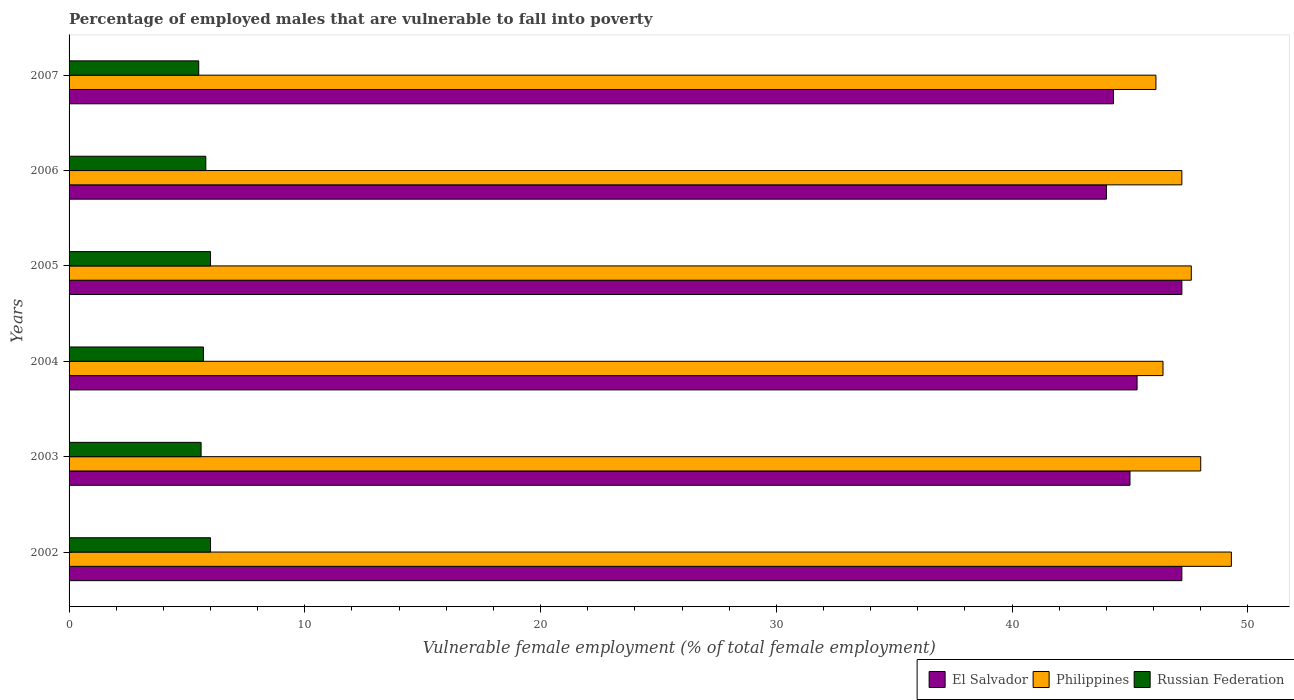How many groups of bars are there?
Give a very brief answer. 6. Are the number of bars on each tick of the Y-axis equal?
Make the answer very short. Yes. How many bars are there on the 4th tick from the top?
Your response must be concise. 3. What is the percentage of employed males who are vulnerable to fall into poverty in Philippines in 2002?
Give a very brief answer. 49.3. Across all years, what is the maximum percentage of employed males who are vulnerable to fall into poverty in El Salvador?
Provide a succinct answer. 47.2. Across all years, what is the minimum percentage of employed males who are vulnerable to fall into poverty in Philippines?
Give a very brief answer. 46.1. In which year was the percentage of employed males who are vulnerable to fall into poverty in El Salvador minimum?
Offer a very short reply. 2006. What is the total percentage of employed males who are vulnerable to fall into poverty in El Salvador in the graph?
Provide a succinct answer. 273. What is the difference between the percentage of employed males who are vulnerable to fall into poverty in Philippines in 2004 and that in 2006?
Give a very brief answer. -0.8. What is the average percentage of employed males who are vulnerable to fall into poverty in El Salvador per year?
Your answer should be very brief. 45.5. In the year 2007, what is the difference between the percentage of employed males who are vulnerable to fall into poverty in El Salvador and percentage of employed males who are vulnerable to fall into poverty in Russian Federation?
Offer a terse response. 38.8. What is the ratio of the percentage of employed males who are vulnerable to fall into poverty in Russian Federation in 2002 to that in 2006?
Your answer should be very brief. 1.03. What is the difference between the highest and the second highest percentage of employed males who are vulnerable to fall into poverty in Russian Federation?
Offer a terse response. 0. What is the difference between the highest and the lowest percentage of employed males who are vulnerable to fall into poverty in El Salvador?
Provide a short and direct response. 3.2. What does the 3rd bar from the top in 2003 represents?
Give a very brief answer. El Salvador. What does the 1st bar from the bottom in 2004 represents?
Provide a succinct answer. El Salvador. Is it the case that in every year, the sum of the percentage of employed males who are vulnerable to fall into poverty in Philippines and percentage of employed males who are vulnerable to fall into poverty in Russian Federation is greater than the percentage of employed males who are vulnerable to fall into poverty in El Salvador?
Offer a very short reply. Yes. How many bars are there?
Give a very brief answer. 18. Are all the bars in the graph horizontal?
Offer a very short reply. Yes. What is the difference between two consecutive major ticks on the X-axis?
Your response must be concise. 10. Are the values on the major ticks of X-axis written in scientific E-notation?
Ensure brevity in your answer.  No. Does the graph contain grids?
Your response must be concise. No. How are the legend labels stacked?
Your response must be concise. Horizontal. What is the title of the graph?
Offer a terse response. Percentage of employed males that are vulnerable to fall into poverty. Does "Albania" appear as one of the legend labels in the graph?
Give a very brief answer. No. What is the label or title of the X-axis?
Ensure brevity in your answer.  Vulnerable female employment (% of total female employment). What is the label or title of the Y-axis?
Provide a short and direct response. Years. What is the Vulnerable female employment (% of total female employment) of El Salvador in 2002?
Your response must be concise. 47.2. What is the Vulnerable female employment (% of total female employment) in Philippines in 2002?
Your response must be concise. 49.3. What is the Vulnerable female employment (% of total female employment) in Philippines in 2003?
Your answer should be compact. 48. What is the Vulnerable female employment (% of total female employment) in Russian Federation in 2003?
Ensure brevity in your answer.  5.6. What is the Vulnerable female employment (% of total female employment) of El Salvador in 2004?
Your answer should be very brief. 45.3. What is the Vulnerable female employment (% of total female employment) of Philippines in 2004?
Your response must be concise. 46.4. What is the Vulnerable female employment (% of total female employment) in Russian Federation in 2004?
Your answer should be very brief. 5.7. What is the Vulnerable female employment (% of total female employment) of El Salvador in 2005?
Give a very brief answer. 47.2. What is the Vulnerable female employment (% of total female employment) of Philippines in 2005?
Provide a succinct answer. 47.6. What is the Vulnerable female employment (% of total female employment) of Russian Federation in 2005?
Your answer should be very brief. 6. What is the Vulnerable female employment (% of total female employment) in Philippines in 2006?
Provide a short and direct response. 47.2. What is the Vulnerable female employment (% of total female employment) of Russian Federation in 2006?
Keep it short and to the point. 5.8. What is the Vulnerable female employment (% of total female employment) of El Salvador in 2007?
Your answer should be compact. 44.3. What is the Vulnerable female employment (% of total female employment) of Philippines in 2007?
Provide a short and direct response. 46.1. What is the Vulnerable female employment (% of total female employment) of Russian Federation in 2007?
Your answer should be very brief. 5.5. Across all years, what is the maximum Vulnerable female employment (% of total female employment) in El Salvador?
Make the answer very short. 47.2. Across all years, what is the maximum Vulnerable female employment (% of total female employment) of Philippines?
Offer a terse response. 49.3. Across all years, what is the minimum Vulnerable female employment (% of total female employment) in El Salvador?
Keep it short and to the point. 44. Across all years, what is the minimum Vulnerable female employment (% of total female employment) in Philippines?
Ensure brevity in your answer.  46.1. What is the total Vulnerable female employment (% of total female employment) of El Salvador in the graph?
Ensure brevity in your answer.  273. What is the total Vulnerable female employment (% of total female employment) of Philippines in the graph?
Offer a terse response. 284.6. What is the total Vulnerable female employment (% of total female employment) of Russian Federation in the graph?
Make the answer very short. 34.6. What is the difference between the Vulnerable female employment (% of total female employment) in El Salvador in 2002 and that in 2003?
Your answer should be compact. 2.2. What is the difference between the Vulnerable female employment (% of total female employment) in Philippines in 2002 and that in 2003?
Your answer should be compact. 1.3. What is the difference between the Vulnerable female employment (% of total female employment) of Russian Federation in 2002 and that in 2003?
Give a very brief answer. 0.4. What is the difference between the Vulnerable female employment (% of total female employment) in Philippines in 2002 and that in 2005?
Your response must be concise. 1.7. What is the difference between the Vulnerable female employment (% of total female employment) in Russian Federation in 2002 and that in 2005?
Provide a short and direct response. 0. What is the difference between the Vulnerable female employment (% of total female employment) of Philippines in 2002 and that in 2006?
Your answer should be very brief. 2.1. What is the difference between the Vulnerable female employment (% of total female employment) in Russian Federation in 2002 and that in 2006?
Offer a very short reply. 0.2. What is the difference between the Vulnerable female employment (% of total female employment) of Philippines in 2002 and that in 2007?
Offer a terse response. 3.2. What is the difference between the Vulnerable female employment (% of total female employment) of Russian Federation in 2002 and that in 2007?
Your answer should be very brief. 0.5. What is the difference between the Vulnerable female employment (% of total female employment) of Philippines in 2003 and that in 2004?
Provide a succinct answer. 1.6. What is the difference between the Vulnerable female employment (% of total female employment) in Russian Federation in 2003 and that in 2004?
Provide a short and direct response. -0.1. What is the difference between the Vulnerable female employment (% of total female employment) in El Salvador in 2003 and that in 2005?
Provide a short and direct response. -2.2. What is the difference between the Vulnerable female employment (% of total female employment) in Philippines in 2003 and that in 2005?
Ensure brevity in your answer.  0.4. What is the difference between the Vulnerable female employment (% of total female employment) in Russian Federation in 2003 and that in 2005?
Make the answer very short. -0.4. What is the difference between the Vulnerable female employment (% of total female employment) of El Salvador in 2003 and that in 2006?
Provide a short and direct response. 1. What is the difference between the Vulnerable female employment (% of total female employment) in Russian Federation in 2003 and that in 2006?
Give a very brief answer. -0.2. What is the difference between the Vulnerable female employment (% of total female employment) in Russian Federation in 2003 and that in 2007?
Offer a terse response. 0.1. What is the difference between the Vulnerable female employment (% of total female employment) of El Salvador in 2004 and that in 2005?
Provide a succinct answer. -1.9. What is the difference between the Vulnerable female employment (% of total female employment) in Philippines in 2004 and that in 2005?
Your answer should be compact. -1.2. What is the difference between the Vulnerable female employment (% of total female employment) in El Salvador in 2004 and that in 2006?
Your answer should be compact. 1.3. What is the difference between the Vulnerable female employment (% of total female employment) in Philippines in 2004 and that in 2006?
Give a very brief answer. -0.8. What is the difference between the Vulnerable female employment (% of total female employment) in Russian Federation in 2004 and that in 2006?
Ensure brevity in your answer.  -0.1. What is the difference between the Vulnerable female employment (% of total female employment) of El Salvador in 2004 and that in 2007?
Provide a succinct answer. 1. What is the difference between the Vulnerable female employment (% of total female employment) of Philippines in 2004 and that in 2007?
Offer a terse response. 0.3. What is the difference between the Vulnerable female employment (% of total female employment) of Russian Federation in 2004 and that in 2007?
Your response must be concise. 0.2. What is the difference between the Vulnerable female employment (% of total female employment) in El Salvador in 2005 and that in 2006?
Offer a very short reply. 3.2. What is the difference between the Vulnerable female employment (% of total female employment) in Philippines in 2005 and that in 2006?
Offer a terse response. 0.4. What is the difference between the Vulnerable female employment (% of total female employment) in Russian Federation in 2005 and that in 2006?
Your response must be concise. 0.2. What is the difference between the Vulnerable female employment (% of total female employment) in El Salvador in 2005 and that in 2007?
Offer a very short reply. 2.9. What is the difference between the Vulnerable female employment (% of total female employment) in Philippines in 2005 and that in 2007?
Ensure brevity in your answer.  1.5. What is the difference between the Vulnerable female employment (% of total female employment) in Russian Federation in 2005 and that in 2007?
Your answer should be compact. 0.5. What is the difference between the Vulnerable female employment (% of total female employment) of Philippines in 2006 and that in 2007?
Your answer should be compact. 1.1. What is the difference between the Vulnerable female employment (% of total female employment) in Russian Federation in 2006 and that in 2007?
Offer a very short reply. 0.3. What is the difference between the Vulnerable female employment (% of total female employment) in El Salvador in 2002 and the Vulnerable female employment (% of total female employment) in Russian Federation in 2003?
Provide a succinct answer. 41.6. What is the difference between the Vulnerable female employment (% of total female employment) of Philippines in 2002 and the Vulnerable female employment (% of total female employment) of Russian Federation in 2003?
Keep it short and to the point. 43.7. What is the difference between the Vulnerable female employment (% of total female employment) in El Salvador in 2002 and the Vulnerable female employment (% of total female employment) in Russian Federation in 2004?
Provide a succinct answer. 41.5. What is the difference between the Vulnerable female employment (% of total female employment) in Philippines in 2002 and the Vulnerable female employment (% of total female employment) in Russian Federation in 2004?
Keep it short and to the point. 43.6. What is the difference between the Vulnerable female employment (% of total female employment) of El Salvador in 2002 and the Vulnerable female employment (% of total female employment) of Russian Federation in 2005?
Ensure brevity in your answer.  41.2. What is the difference between the Vulnerable female employment (% of total female employment) of Philippines in 2002 and the Vulnerable female employment (% of total female employment) of Russian Federation in 2005?
Offer a terse response. 43.3. What is the difference between the Vulnerable female employment (% of total female employment) of El Salvador in 2002 and the Vulnerable female employment (% of total female employment) of Philippines in 2006?
Make the answer very short. 0. What is the difference between the Vulnerable female employment (% of total female employment) of El Salvador in 2002 and the Vulnerable female employment (% of total female employment) of Russian Federation in 2006?
Your answer should be very brief. 41.4. What is the difference between the Vulnerable female employment (% of total female employment) in Philippines in 2002 and the Vulnerable female employment (% of total female employment) in Russian Federation in 2006?
Offer a terse response. 43.5. What is the difference between the Vulnerable female employment (% of total female employment) of El Salvador in 2002 and the Vulnerable female employment (% of total female employment) of Russian Federation in 2007?
Your answer should be very brief. 41.7. What is the difference between the Vulnerable female employment (% of total female employment) of Philippines in 2002 and the Vulnerable female employment (% of total female employment) of Russian Federation in 2007?
Your answer should be compact. 43.8. What is the difference between the Vulnerable female employment (% of total female employment) of El Salvador in 2003 and the Vulnerable female employment (% of total female employment) of Russian Federation in 2004?
Your answer should be very brief. 39.3. What is the difference between the Vulnerable female employment (% of total female employment) of Philippines in 2003 and the Vulnerable female employment (% of total female employment) of Russian Federation in 2004?
Provide a succinct answer. 42.3. What is the difference between the Vulnerable female employment (% of total female employment) of El Salvador in 2003 and the Vulnerable female employment (% of total female employment) of Philippines in 2005?
Give a very brief answer. -2.6. What is the difference between the Vulnerable female employment (% of total female employment) of El Salvador in 2003 and the Vulnerable female employment (% of total female employment) of Russian Federation in 2006?
Your answer should be very brief. 39.2. What is the difference between the Vulnerable female employment (% of total female employment) of Philippines in 2003 and the Vulnerable female employment (% of total female employment) of Russian Federation in 2006?
Your answer should be very brief. 42.2. What is the difference between the Vulnerable female employment (% of total female employment) in El Salvador in 2003 and the Vulnerable female employment (% of total female employment) in Russian Federation in 2007?
Your answer should be compact. 39.5. What is the difference between the Vulnerable female employment (% of total female employment) of Philippines in 2003 and the Vulnerable female employment (% of total female employment) of Russian Federation in 2007?
Your response must be concise. 42.5. What is the difference between the Vulnerable female employment (% of total female employment) of El Salvador in 2004 and the Vulnerable female employment (% of total female employment) of Philippines in 2005?
Keep it short and to the point. -2.3. What is the difference between the Vulnerable female employment (% of total female employment) in El Salvador in 2004 and the Vulnerable female employment (% of total female employment) in Russian Federation in 2005?
Provide a succinct answer. 39.3. What is the difference between the Vulnerable female employment (% of total female employment) in Philippines in 2004 and the Vulnerable female employment (% of total female employment) in Russian Federation in 2005?
Make the answer very short. 40.4. What is the difference between the Vulnerable female employment (% of total female employment) in El Salvador in 2004 and the Vulnerable female employment (% of total female employment) in Russian Federation in 2006?
Provide a short and direct response. 39.5. What is the difference between the Vulnerable female employment (% of total female employment) in Philippines in 2004 and the Vulnerable female employment (% of total female employment) in Russian Federation in 2006?
Provide a short and direct response. 40.6. What is the difference between the Vulnerable female employment (% of total female employment) of El Salvador in 2004 and the Vulnerable female employment (% of total female employment) of Russian Federation in 2007?
Keep it short and to the point. 39.8. What is the difference between the Vulnerable female employment (% of total female employment) of Philippines in 2004 and the Vulnerable female employment (% of total female employment) of Russian Federation in 2007?
Your answer should be very brief. 40.9. What is the difference between the Vulnerable female employment (% of total female employment) in El Salvador in 2005 and the Vulnerable female employment (% of total female employment) in Philippines in 2006?
Your answer should be very brief. 0. What is the difference between the Vulnerable female employment (% of total female employment) of El Salvador in 2005 and the Vulnerable female employment (% of total female employment) of Russian Federation in 2006?
Ensure brevity in your answer.  41.4. What is the difference between the Vulnerable female employment (% of total female employment) in Philippines in 2005 and the Vulnerable female employment (% of total female employment) in Russian Federation in 2006?
Ensure brevity in your answer.  41.8. What is the difference between the Vulnerable female employment (% of total female employment) in El Salvador in 2005 and the Vulnerable female employment (% of total female employment) in Philippines in 2007?
Keep it short and to the point. 1.1. What is the difference between the Vulnerable female employment (% of total female employment) in El Salvador in 2005 and the Vulnerable female employment (% of total female employment) in Russian Federation in 2007?
Your answer should be very brief. 41.7. What is the difference between the Vulnerable female employment (% of total female employment) in Philippines in 2005 and the Vulnerable female employment (% of total female employment) in Russian Federation in 2007?
Ensure brevity in your answer.  42.1. What is the difference between the Vulnerable female employment (% of total female employment) in El Salvador in 2006 and the Vulnerable female employment (% of total female employment) in Philippines in 2007?
Make the answer very short. -2.1. What is the difference between the Vulnerable female employment (% of total female employment) in El Salvador in 2006 and the Vulnerable female employment (% of total female employment) in Russian Federation in 2007?
Your answer should be very brief. 38.5. What is the difference between the Vulnerable female employment (% of total female employment) in Philippines in 2006 and the Vulnerable female employment (% of total female employment) in Russian Federation in 2007?
Give a very brief answer. 41.7. What is the average Vulnerable female employment (% of total female employment) in El Salvador per year?
Keep it short and to the point. 45.5. What is the average Vulnerable female employment (% of total female employment) of Philippines per year?
Make the answer very short. 47.43. What is the average Vulnerable female employment (% of total female employment) in Russian Federation per year?
Offer a very short reply. 5.77. In the year 2002, what is the difference between the Vulnerable female employment (% of total female employment) in El Salvador and Vulnerable female employment (% of total female employment) in Russian Federation?
Your response must be concise. 41.2. In the year 2002, what is the difference between the Vulnerable female employment (% of total female employment) of Philippines and Vulnerable female employment (% of total female employment) of Russian Federation?
Ensure brevity in your answer.  43.3. In the year 2003, what is the difference between the Vulnerable female employment (% of total female employment) in El Salvador and Vulnerable female employment (% of total female employment) in Philippines?
Your response must be concise. -3. In the year 2003, what is the difference between the Vulnerable female employment (% of total female employment) in El Salvador and Vulnerable female employment (% of total female employment) in Russian Federation?
Your answer should be very brief. 39.4. In the year 2003, what is the difference between the Vulnerable female employment (% of total female employment) in Philippines and Vulnerable female employment (% of total female employment) in Russian Federation?
Provide a succinct answer. 42.4. In the year 2004, what is the difference between the Vulnerable female employment (% of total female employment) of El Salvador and Vulnerable female employment (% of total female employment) of Russian Federation?
Your answer should be compact. 39.6. In the year 2004, what is the difference between the Vulnerable female employment (% of total female employment) in Philippines and Vulnerable female employment (% of total female employment) in Russian Federation?
Provide a short and direct response. 40.7. In the year 2005, what is the difference between the Vulnerable female employment (% of total female employment) in El Salvador and Vulnerable female employment (% of total female employment) in Philippines?
Provide a short and direct response. -0.4. In the year 2005, what is the difference between the Vulnerable female employment (% of total female employment) of El Salvador and Vulnerable female employment (% of total female employment) of Russian Federation?
Offer a very short reply. 41.2. In the year 2005, what is the difference between the Vulnerable female employment (% of total female employment) of Philippines and Vulnerable female employment (% of total female employment) of Russian Federation?
Ensure brevity in your answer.  41.6. In the year 2006, what is the difference between the Vulnerable female employment (% of total female employment) of El Salvador and Vulnerable female employment (% of total female employment) of Russian Federation?
Your response must be concise. 38.2. In the year 2006, what is the difference between the Vulnerable female employment (% of total female employment) of Philippines and Vulnerable female employment (% of total female employment) of Russian Federation?
Offer a terse response. 41.4. In the year 2007, what is the difference between the Vulnerable female employment (% of total female employment) of El Salvador and Vulnerable female employment (% of total female employment) of Philippines?
Keep it short and to the point. -1.8. In the year 2007, what is the difference between the Vulnerable female employment (% of total female employment) in El Salvador and Vulnerable female employment (% of total female employment) in Russian Federation?
Offer a very short reply. 38.8. In the year 2007, what is the difference between the Vulnerable female employment (% of total female employment) of Philippines and Vulnerable female employment (% of total female employment) of Russian Federation?
Offer a terse response. 40.6. What is the ratio of the Vulnerable female employment (% of total female employment) of El Salvador in 2002 to that in 2003?
Provide a succinct answer. 1.05. What is the ratio of the Vulnerable female employment (% of total female employment) in Philippines in 2002 to that in 2003?
Your answer should be compact. 1.03. What is the ratio of the Vulnerable female employment (% of total female employment) of Russian Federation in 2002 to that in 2003?
Ensure brevity in your answer.  1.07. What is the ratio of the Vulnerable female employment (% of total female employment) of El Salvador in 2002 to that in 2004?
Offer a very short reply. 1.04. What is the ratio of the Vulnerable female employment (% of total female employment) in Russian Federation in 2002 to that in 2004?
Keep it short and to the point. 1.05. What is the ratio of the Vulnerable female employment (% of total female employment) in Philippines in 2002 to that in 2005?
Offer a very short reply. 1.04. What is the ratio of the Vulnerable female employment (% of total female employment) of El Salvador in 2002 to that in 2006?
Ensure brevity in your answer.  1.07. What is the ratio of the Vulnerable female employment (% of total female employment) of Philippines in 2002 to that in 2006?
Keep it short and to the point. 1.04. What is the ratio of the Vulnerable female employment (% of total female employment) of Russian Federation in 2002 to that in 2006?
Offer a terse response. 1.03. What is the ratio of the Vulnerable female employment (% of total female employment) in El Salvador in 2002 to that in 2007?
Give a very brief answer. 1.07. What is the ratio of the Vulnerable female employment (% of total female employment) in Philippines in 2002 to that in 2007?
Offer a terse response. 1.07. What is the ratio of the Vulnerable female employment (% of total female employment) of El Salvador in 2003 to that in 2004?
Offer a terse response. 0.99. What is the ratio of the Vulnerable female employment (% of total female employment) in Philippines in 2003 to that in 2004?
Provide a succinct answer. 1.03. What is the ratio of the Vulnerable female employment (% of total female employment) in Russian Federation in 2003 to that in 2004?
Your response must be concise. 0.98. What is the ratio of the Vulnerable female employment (% of total female employment) in El Salvador in 2003 to that in 2005?
Provide a succinct answer. 0.95. What is the ratio of the Vulnerable female employment (% of total female employment) in Philippines in 2003 to that in 2005?
Your answer should be compact. 1.01. What is the ratio of the Vulnerable female employment (% of total female employment) in El Salvador in 2003 to that in 2006?
Ensure brevity in your answer.  1.02. What is the ratio of the Vulnerable female employment (% of total female employment) of Philippines in 2003 to that in 2006?
Keep it short and to the point. 1.02. What is the ratio of the Vulnerable female employment (% of total female employment) of Russian Federation in 2003 to that in 2006?
Provide a succinct answer. 0.97. What is the ratio of the Vulnerable female employment (% of total female employment) in El Salvador in 2003 to that in 2007?
Make the answer very short. 1.02. What is the ratio of the Vulnerable female employment (% of total female employment) in Philippines in 2003 to that in 2007?
Your response must be concise. 1.04. What is the ratio of the Vulnerable female employment (% of total female employment) in Russian Federation in 2003 to that in 2007?
Ensure brevity in your answer.  1.02. What is the ratio of the Vulnerable female employment (% of total female employment) in El Salvador in 2004 to that in 2005?
Make the answer very short. 0.96. What is the ratio of the Vulnerable female employment (% of total female employment) in Philippines in 2004 to that in 2005?
Your response must be concise. 0.97. What is the ratio of the Vulnerable female employment (% of total female employment) of El Salvador in 2004 to that in 2006?
Provide a succinct answer. 1.03. What is the ratio of the Vulnerable female employment (% of total female employment) in Philippines in 2004 to that in 2006?
Ensure brevity in your answer.  0.98. What is the ratio of the Vulnerable female employment (% of total female employment) in Russian Federation in 2004 to that in 2006?
Give a very brief answer. 0.98. What is the ratio of the Vulnerable female employment (% of total female employment) in El Salvador in 2004 to that in 2007?
Provide a succinct answer. 1.02. What is the ratio of the Vulnerable female employment (% of total female employment) of Russian Federation in 2004 to that in 2007?
Offer a very short reply. 1.04. What is the ratio of the Vulnerable female employment (% of total female employment) of El Salvador in 2005 to that in 2006?
Offer a terse response. 1.07. What is the ratio of the Vulnerable female employment (% of total female employment) of Philippines in 2005 to that in 2006?
Make the answer very short. 1.01. What is the ratio of the Vulnerable female employment (% of total female employment) of Russian Federation in 2005 to that in 2006?
Offer a very short reply. 1.03. What is the ratio of the Vulnerable female employment (% of total female employment) in El Salvador in 2005 to that in 2007?
Make the answer very short. 1.07. What is the ratio of the Vulnerable female employment (% of total female employment) in Philippines in 2005 to that in 2007?
Provide a short and direct response. 1.03. What is the ratio of the Vulnerable female employment (% of total female employment) of El Salvador in 2006 to that in 2007?
Provide a short and direct response. 0.99. What is the ratio of the Vulnerable female employment (% of total female employment) of Philippines in 2006 to that in 2007?
Your answer should be very brief. 1.02. What is the ratio of the Vulnerable female employment (% of total female employment) in Russian Federation in 2006 to that in 2007?
Provide a succinct answer. 1.05. What is the difference between the highest and the second highest Vulnerable female employment (% of total female employment) of El Salvador?
Ensure brevity in your answer.  0. What is the difference between the highest and the lowest Vulnerable female employment (% of total female employment) in El Salvador?
Your response must be concise. 3.2. What is the difference between the highest and the lowest Vulnerable female employment (% of total female employment) in Philippines?
Keep it short and to the point. 3.2. What is the difference between the highest and the lowest Vulnerable female employment (% of total female employment) in Russian Federation?
Offer a terse response. 0.5. 